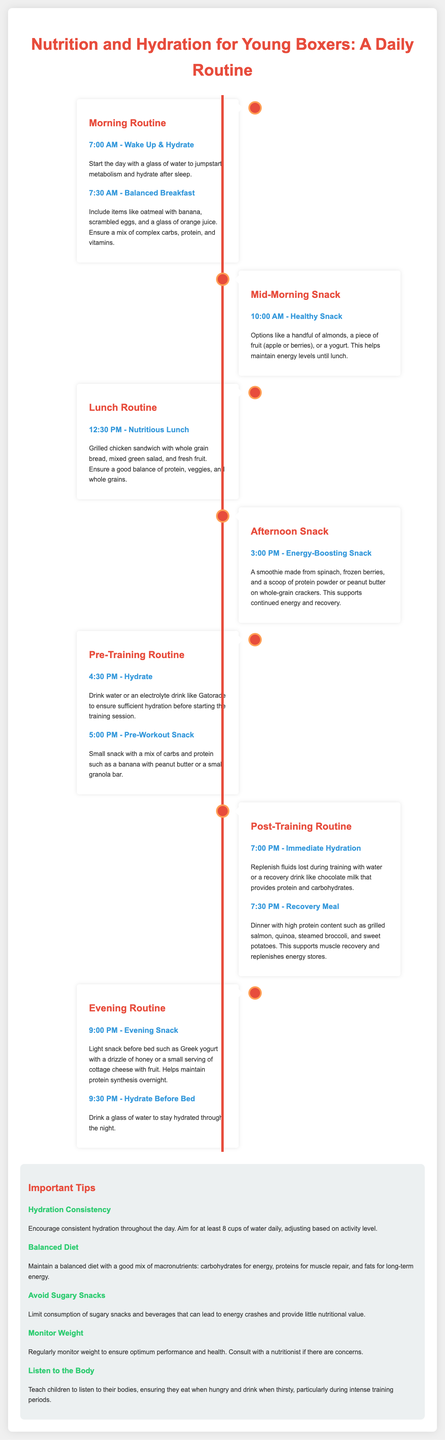what time does hydration start in the morning? The document states that hydration starts at 7:00 AM with a glass of water.
Answer: 7:00 AM what should be included in a balanced breakfast? The document suggests items like oatmeal with banana, scrambled eggs, and a glass of orange juice for a balanced breakfast.
Answer: oatmeal with banana, scrambled eggs, and orange juice what is a recommended mid-morning snack? The document lists a handful of almonds, a piece of fruit like an apple or berries, or yogurt as healthy snack options.
Answer: almonds, fruit, or yogurt what is the purpose of the pre-workout snack? The document states that the pre-workout snack is meant to provide a mix of carbs and protein.
Answer: provide mix of carbs and protein what is an example of a post-training recovery meal? The document mentions grilled salmon, quinoa, steamed broccoli, and sweet potatoes as a recovery meal.
Answer: grilled salmon, quinoa, broccoli, and sweet potatoes how many cups of water should young boxers aim for daily? The document advises aiming for at least 8 cups of water daily.
Answer: 8 cups what types of foods should be limited during training? The document advises to limit the consumption of sugary snacks and beverages.
Answer: sugary snacks and beverages when should young boxers hydrate before bed? The document states that hydration before bed should occur at 9:30 PM.
Answer: 9:30 PM 